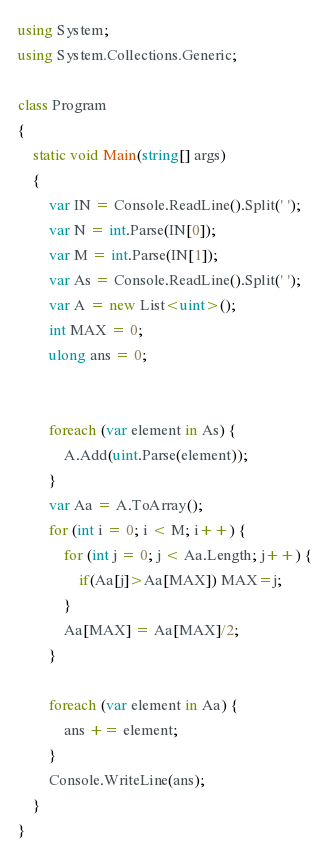Convert code to text. <code><loc_0><loc_0><loc_500><loc_500><_C#_>using System;
using System.Collections.Generic;

class Program
{
	static void Main(string[] args)
	{
		var IN = Console.ReadLine().Split(' ');
		var N = int.Parse(IN[0]);
		var M = int.Parse(IN[1]);
		var As = Console.ReadLine().Split(' ');
		var A = new List<uint>();
		int MAX = 0;
		ulong ans = 0;
		
		
		foreach (var element in As) {
			A.Add(uint.Parse(element));
		}
		var Aa = A.ToArray();
		for (int i = 0; i < M; i++) {
			for (int j = 0; j < Aa.Length; j++) {
				if(Aa[j]>Aa[MAX]) MAX=j;
			}
			Aa[MAX] = Aa[MAX]/2;
		}
		
		foreach (var element in Aa) {
			ans += element;
		}
		Console.WriteLine(ans);
	}
}</code> 